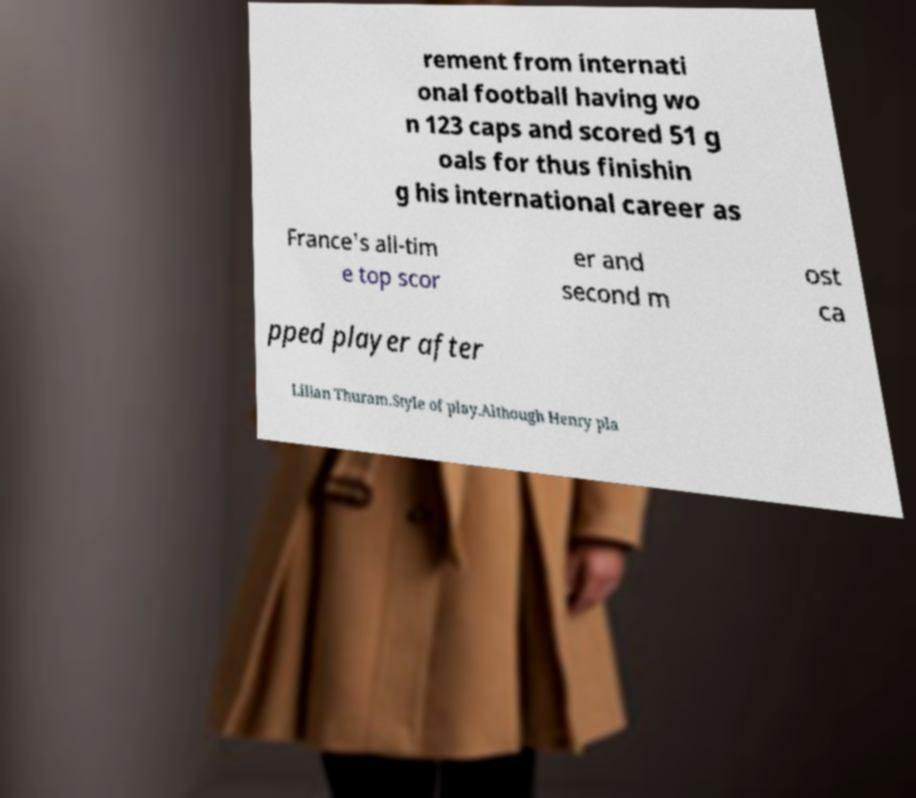There's text embedded in this image that I need extracted. Can you transcribe it verbatim? rement from internati onal football having wo n 123 caps and scored 51 g oals for thus finishin g his international career as France's all-tim e top scor er and second m ost ca pped player after Lilian Thuram.Style of play.Although Henry pla 